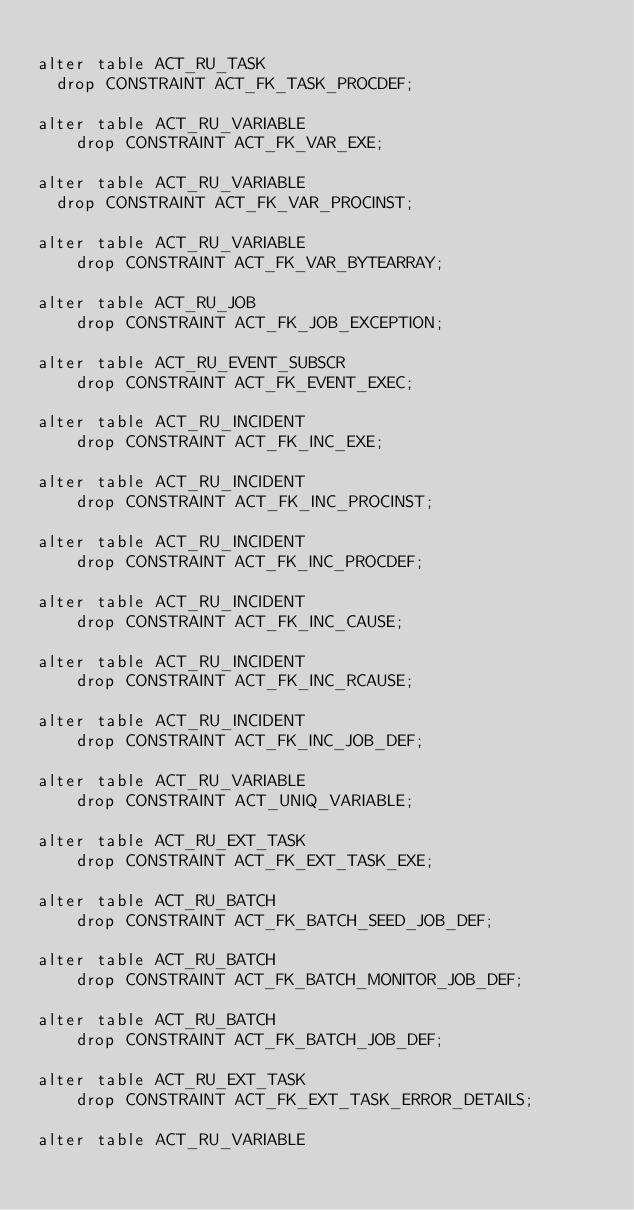Convert code to text. <code><loc_0><loc_0><loc_500><loc_500><_SQL_>
alter table ACT_RU_TASK
	drop CONSTRAINT ACT_FK_TASK_PROCDEF;

alter table ACT_RU_VARIABLE
    drop CONSTRAINT ACT_FK_VAR_EXE;

alter table ACT_RU_VARIABLE
	drop CONSTRAINT ACT_FK_VAR_PROCINST;

alter table ACT_RU_VARIABLE
    drop CONSTRAINT ACT_FK_VAR_BYTEARRAY;

alter table ACT_RU_JOB
    drop CONSTRAINT ACT_FK_JOB_EXCEPTION;

alter table ACT_RU_EVENT_SUBSCR
    drop CONSTRAINT ACT_FK_EVENT_EXEC;

alter table ACT_RU_INCIDENT
    drop CONSTRAINT ACT_FK_INC_EXE;

alter table ACT_RU_INCIDENT
    drop CONSTRAINT ACT_FK_INC_PROCINST;

alter table ACT_RU_INCIDENT
    drop CONSTRAINT ACT_FK_INC_PROCDEF;

alter table ACT_RU_INCIDENT
    drop CONSTRAINT ACT_FK_INC_CAUSE;

alter table ACT_RU_INCIDENT
    drop CONSTRAINT ACT_FK_INC_RCAUSE;

alter table ACT_RU_INCIDENT
    drop CONSTRAINT ACT_FK_INC_JOB_DEF;

alter table ACT_RU_VARIABLE
    drop CONSTRAINT ACT_UNIQ_VARIABLE;

alter table ACT_RU_EXT_TASK
    drop CONSTRAINT ACT_FK_EXT_TASK_EXE;

alter table ACT_RU_BATCH
    drop CONSTRAINT ACT_FK_BATCH_SEED_JOB_DEF;

alter table ACT_RU_BATCH
    drop CONSTRAINT ACT_FK_BATCH_MONITOR_JOB_DEF;

alter table ACT_RU_BATCH
    drop CONSTRAINT ACT_FK_BATCH_JOB_DEF;

alter table ACT_RU_EXT_TASK
    drop CONSTRAINT ACT_FK_EXT_TASK_ERROR_DETAILS;

alter table ACT_RU_VARIABLE</code> 